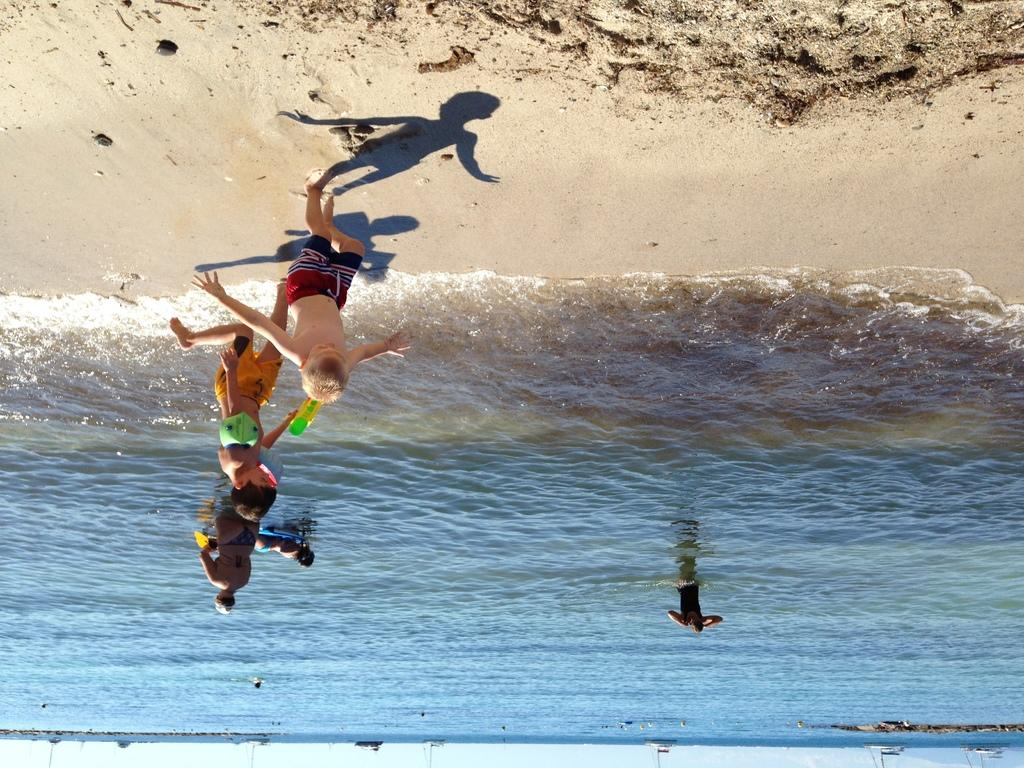What type of environment is depicted in the image? The image features water and sand, suggesting a beach or coastal setting. What can be seen in the water in the image? There are boats visible in the water in the image. Are there any people present in the image? Yes, there are people in the image. How many masses can be seen in the image? There is no mass present in the image. Can you tell me how many times the people in the image sneeze? There is no indication of anyone sneezing in the image. What type of lighting fixture is visible in the image? There is no lighting fixture, such as a bulb, present in the image. 